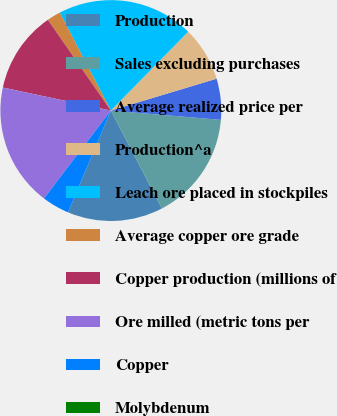Convert chart. <chart><loc_0><loc_0><loc_500><loc_500><pie_chart><fcel>Production<fcel>Sales excluding purchases<fcel>Average realized price per<fcel>Production^a<fcel>Leach ore placed in stockpiles<fcel>Average copper ore grade<fcel>Copper production (millions of<fcel>Ore milled (metric tons per<fcel>Copper<fcel>Molybdenum<nl><fcel>14.0%<fcel>16.0%<fcel>6.0%<fcel>8.0%<fcel>20.0%<fcel>2.0%<fcel>12.0%<fcel>18.0%<fcel>4.0%<fcel>0.0%<nl></chart> 